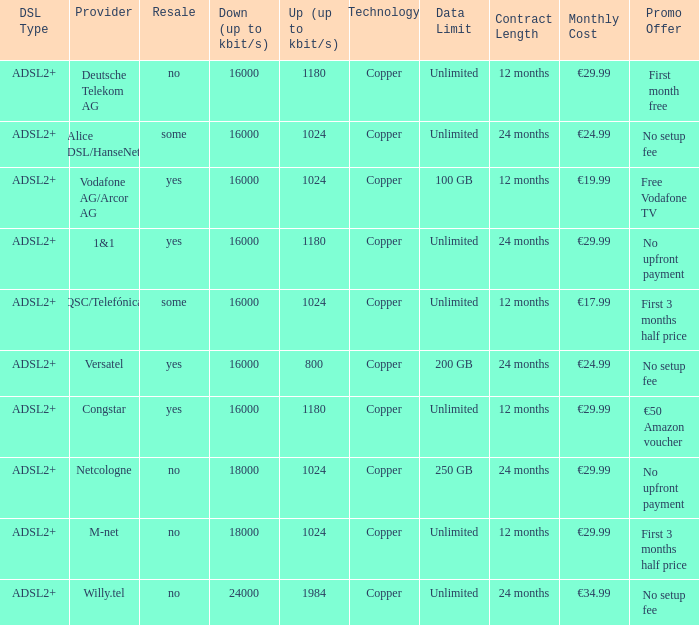What is the resale category for the provider NetCologne? No. 